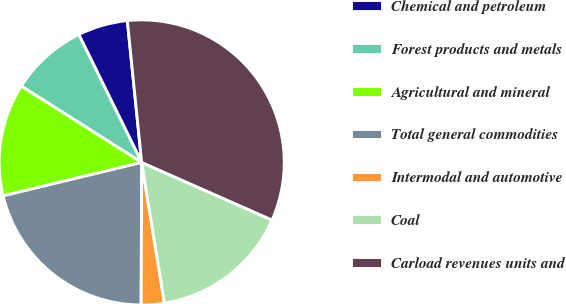Convert chart to OTSL. <chart><loc_0><loc_0><loc_500><loc_500><pie_chart><fcel>Chemical and petroleum<fcel>Forest products and metals<fcel>Agricultural and mineral<fcel>Total general commodities<fcel>Intermodal and automotive<fcel>Coal<fcel>Carload revenues units and<nl><fcel>5.67%<fcel>8.73%<fcel>12.76%<fcel>21.17%<fcel>2.61%<fcel>15.82%<fcel>33.22%<nl></chart> 